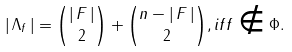Convert formula to latex. <formula><loc_0><loc_0><loc_500><loc_500>| \, \Lambda _ { f } \, | = \binom { | \, F \, | } { 2 } + \binom { n - | \, F \, | } { 2 } , i f f \notin \Phi .</formula> 